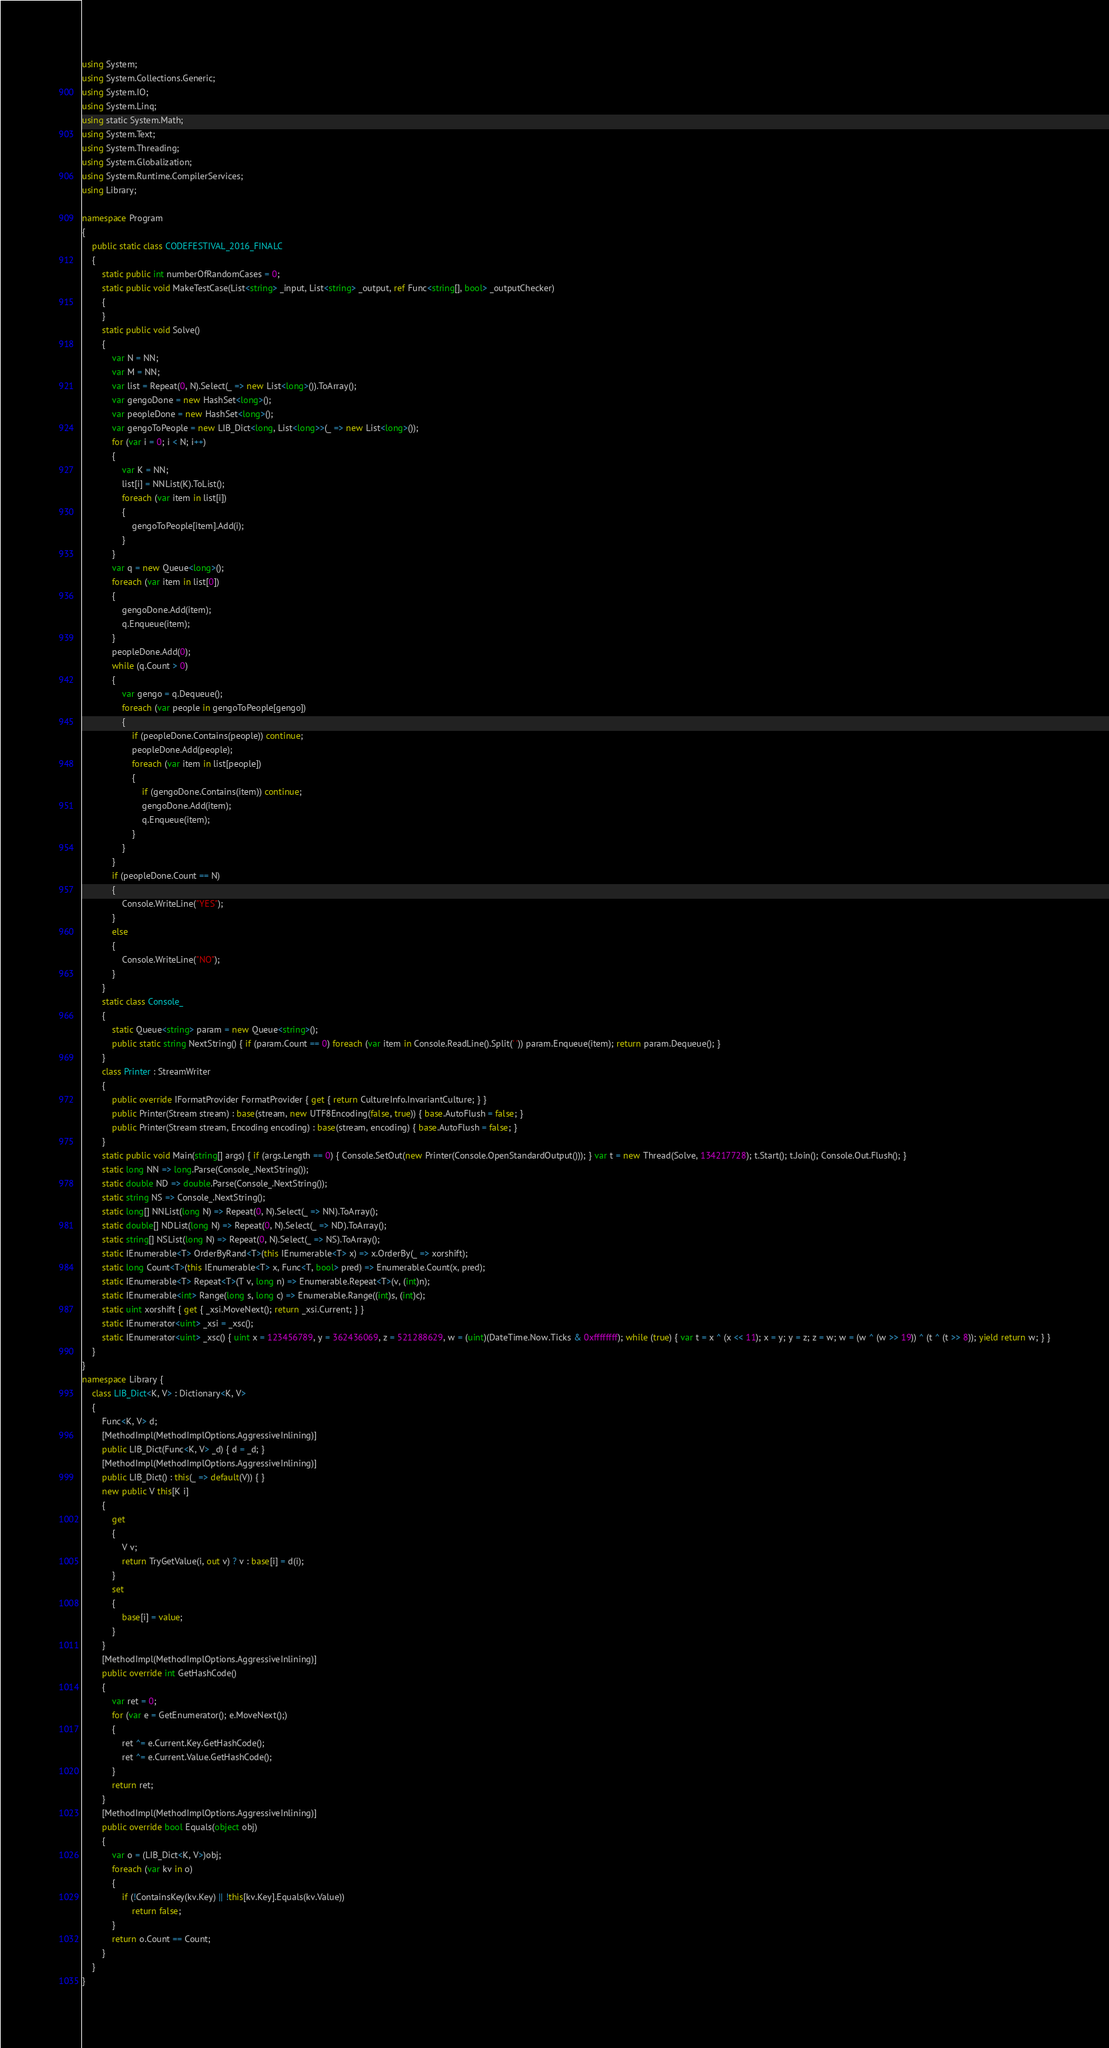Convert code to text. <code><loc_0><loc_0><loc_500><loc_500><_C#_>using System;
using System.Collections.Generic;
using System.IO;
using System.Linq;
using static System.Math;
using System.Text;
using System.Threading;
using System.Globalization;
using System.Runtime.CompilerServices;
using Library;

namespace Program
{
    public static class CODEFESTIVAL_2016_FINALC
    {
        static public int numberOfRandomCases = 0;
        static public void MakeTestCase(List<string> _input, List<string> _output, ref Func<string[], bool> _outputChecker)
        {
        }
        static public void Solve()
        {
            var N = NN;
            var M = NN;
            var list = Repeat(0, N).Select(_ => new List<long>()).ToArray();
            var gengoDone = new HashSet<long>();
            var peopleDone = new HashSet<long>();
            var gengoToPeople = new LIB_Dict<long, List<long>>(_ => new List<long>());
            for (var i = 0; i < N; i++)
            {
                var K = NN;
                list[i] = NNList(K).ToList();
                foreach (var item in list[i])
                {
                    gengoToPeople[item].Add(i);
                }
            }
            var q = new Queue<long>();
            foreach (var item in list[0])
            {
                gengoDone.Add(item);
                q.Enqueue(item);
            }
            peopleDone.Add(0);
            while (q.Count > 0)
            {
                var gengo = q.Dequeue();
                foreach (var people in gengoToPeople[gengo])
                {
                    if (peopleDone.Contains(people)) continue;
                    peopleDone.Add(people);
                    foreach (var item in list[people])
                    {
                        if (gengoDone.Contains(item)) continue;
                        gengoDone.Add(item);
                        q.Enqueue(item);
                    }
                }
            }
            if (peopleDone.Count == N)
            {
                Console.WriteLine("YES");
            }
            else
            {
                Console.WriteLine("NO");
            }
        }
        static class Console_
        {
            static Queue<string> param = new Queue<string>();
            public static string NextString() { if (param.Count == 0) foreach (var item in Console.ReadLine().Split(' ')) param.Enqueue(item); return param.Dequeue(); }
        }
        class Printer : StreamWriter
        {
            public override IFormatProvider FormatProvider { get { return CultureInfo.InvariantCulture; } }
            public Printer(Stream stream) : base(stream, new UTF8Encoding(false, true)) { base.AutoFlush = false; }
            public Printer(Stream stream, Encoding encoding) : base(stream, encoding) { base.AutoFlush = false; }
        }
        static public void Main(string[] args) { if (args.Length == 0) { Console.SetOut(new Printer(Console.OpenStandardOutput())); } var t = new Thread(Solve, 134217728); t.Start(); t.Join(); Console.Out.Flush(); }
        static long NN => long.Parse(Console_.NextString());
        static double ND => double.Parse(Console_.NextString());
        static string NS => Console_.NextString();
        static long[] NNList(long N) => Repeat(0, N).Select(_ => NN).ToArray();
        static double[] NDList(long N) => Repeat(0, N).Select(_ => ND).ToArray();
        static string[] NSList(long N) => Repeat(0, N).Select(_ => NS).ToArray();
        static IEnumerable<T> OrderByRand<T>(this IEnumerable<T> x) => x.OrderBy(_ => xorshift);
        static long Count<T>(this IEnumerable<T> x, Func<T, bool> pred) => Enumerable.Count(x, pred);
        static IEnumerable<T> Repeat<T>(T v, long n) => Enumerable.Repeat<T>(v, (int)n);
        static IEnumerable<int> Range(long s, long c) => Enumerable.Range((int)s, (int)c);
        static uint xorshift { get { _xsi.MoveNext(); return _xsi.Current; } }
        static IEnumerator<uint> _xsi = _xsc();
        static IEnumerator<uint> _xsc() { uint x = 123456789, y = 362436069, z = 521288629, w = (uint)(DateTime.Now.Ticks & 0xffffffff); while (true) { var t = x ^ (x << 11); x = y; y = z; z = w; w = (w ^ (w >> 19)) ^ (t ^ (t >> 8)); yield return w; } }
    }
}
namespace Library {
    class LIB_Dict<K, V> : Dictionary<K, V>
    {
        Func<K, V> d;
        [MethodImpl(MethodImplOptions.AggressiveInlining)]
        public LIB_Dict(Func<K, V> _d) { d = _d; }
        [MethodImpl(MethodImplOptions.AggressiveInlining)]
        public LIB_Dict() : this(_ => default(V)) { }
        new public V this[K i]
        {
            get
            {
                V v;
                return TryGetValue(i, out v) ? v : base[i] = d(i);
            }
            set
            {
                base[i] = value;
            }
        }
        [MethodImpl(MethodImplOptions.AggressiveInlining)]
        public override int GetHashCode()
        {
            var ret = 0;
            for (var e = GetEnumerator(); e.MoveNext();)
            {
                ret ^= e.Current.Key.GetHashCode();
                ret ^= e.Current.Value.GetHashCode();
            }
            return ret;
        }
        [MethodImpl(MethodImplOptions.AggressiveInlining)]
        public override bool Equals(object obj)
        {
            var o = (LIB_Dict<K, V>)obj;
            foreach (var kv in o)
            {
                if (!ContainsKey(kv.Key) || !this[kv.Key].Equals(kv.Value))
                    return false;
            }
            return o.Count == Count;
        }
    }
}
</code> 